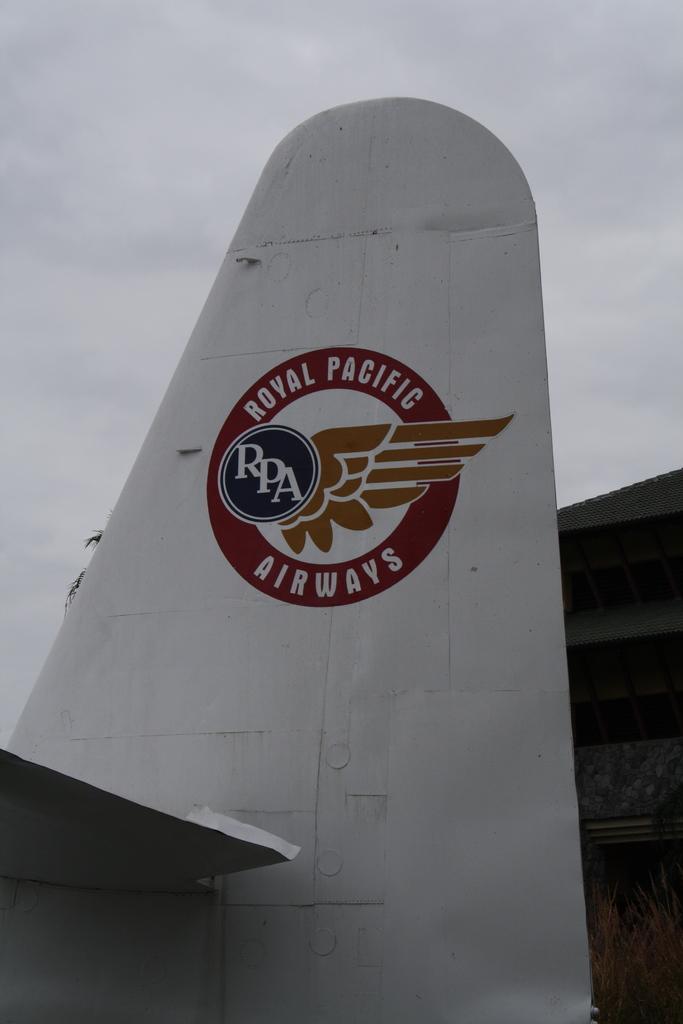How would you summarize this image in a sentence or two? In this picture we can see plane's wing near to the shed. here we can see logo of a company. On the top we can see sky and clouds. Here it's a tree. 